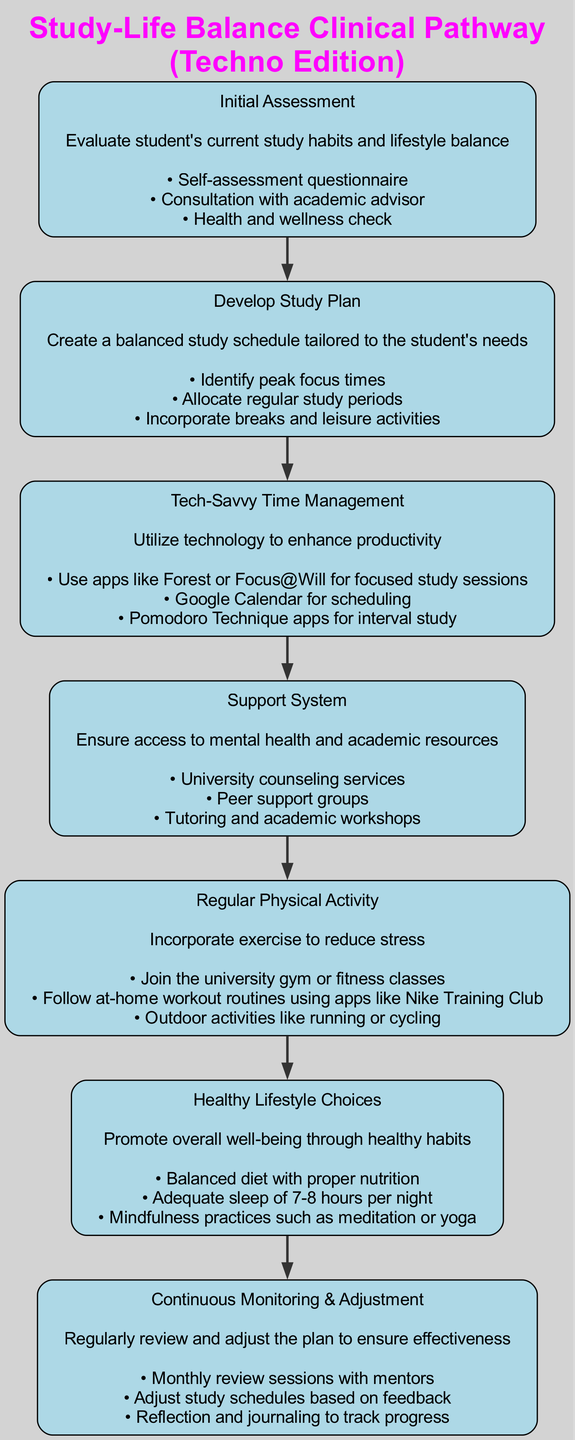What is the total number of nodes in the diagram? The diagram contains 7 nodes that represent different stages in the management of study-life balance. They are numbered from 1 to 7.
Answer: 7 What is the title of the first node? The title of the first node in the diagram is "Initial Assessment." Each node is labeled with its title as indicated in the structure.
Answer: Initial Assessment Which node comes after the "Tech-Savvy Time Management" node? The "Tech-Savvy Time Management" node is node number 3, and the node that follows it is node number 4, titled "Support System." The connections between nodes indicate their order.
Answer: Support System What key step is highlighted in the "Develop Study Plan" node? The "Develop Study Plan" node has several key steps, one of which is "Incorporate breaks and leisure activities." This is mentioned as one of the action points in that node.
Answer: Incorporate breaks and leisure activities Which node focuses on physical activity? The node titled "Regular Physical Activity" specifically addresses the importance of exercise and outlines associated key steps. This title directly indicates its focus.
Answer: Regular Physical Activity What type of resources are mentioned in the "Support System" node? The "Support System" node includes access to "University counseling services," which focuses on mental health resources as part of its description. This reflects the types of support available.
Answer: University counseling services How often should the "Continuous Monitoring & Adjustment" node be reviewed? The node states that "Monthly review sessions with mentors" should take place, indicating that this process occurs every month.
Answer: Monthly Which node emphasizes mindfulness practices? The "Healthy Lifestyle Choices" node mentions "Mindfulness practices such as meditation or yoga," which highlights the focus on mental wellness through mindfulness.
Answer: Healthy Lifestyle Choices 